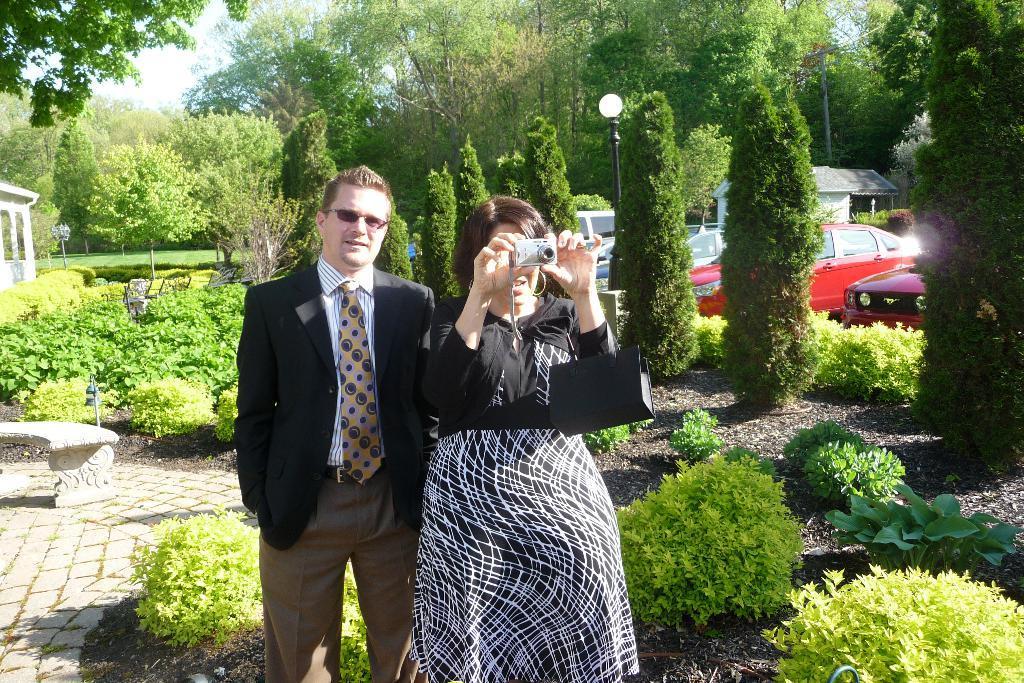Can you describe this image briefly? In the picture I can see a man and a woman are standing on the ground, among them the woman is holding a camera in hands. In the background I can see plants, trees, vehicles, the sky and some other objects. 